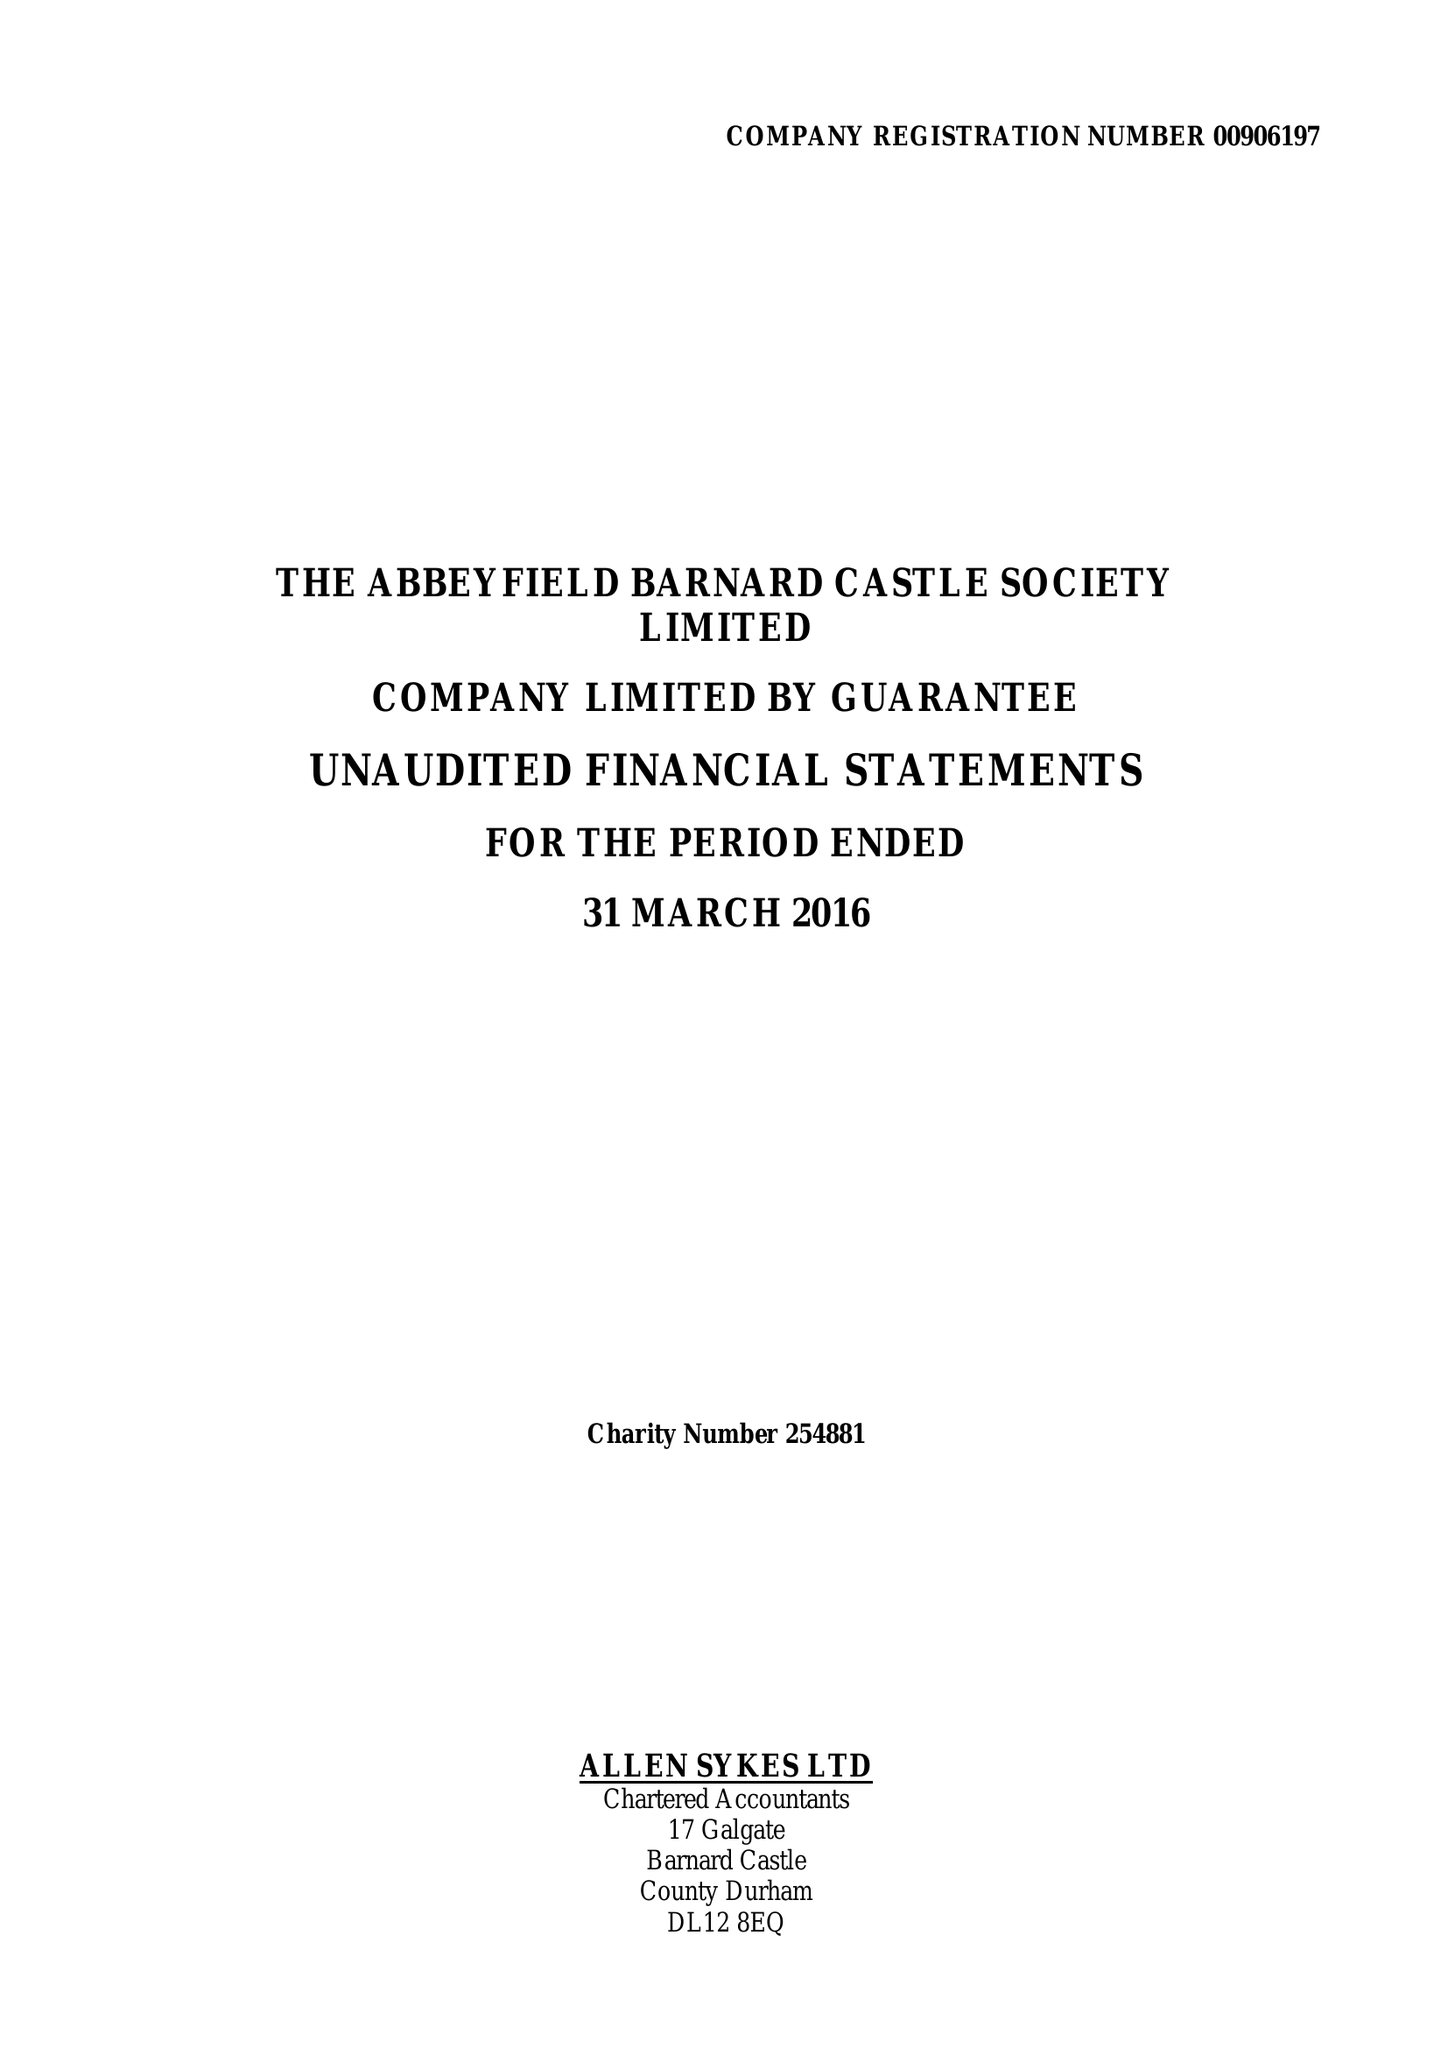What is the value for the spending_annually_in_british_pounds?
Answer the question using a single word or phrase. 156098.00 